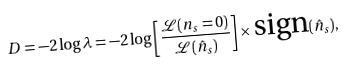Convert formula to latex. <formula><loc_0><loc_0><loc_500><loc_500>D = - 2 \log \lambda = - 2 \log \left [ \frac { \mathcal { L } ( n _ { s } = 0 ) } { \mathcal { L } ( \hat { n } _ { s } ) } \right ] \times \text {sign} ( \hat { n } _ { s } ) ,</formula> 